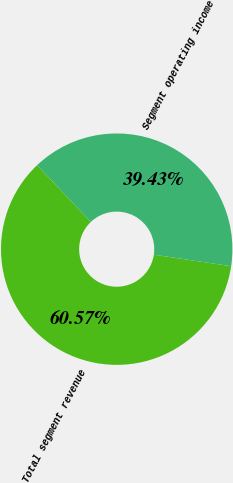Convert chart to OTSL. <chart><loc_0><loc_0><loc_500><loc_500><pie_chart><fcel>Total segment revenue<fcel>Segment operating income<nl><fcel>60.57%<fcel>39.43%<nl></chart> 